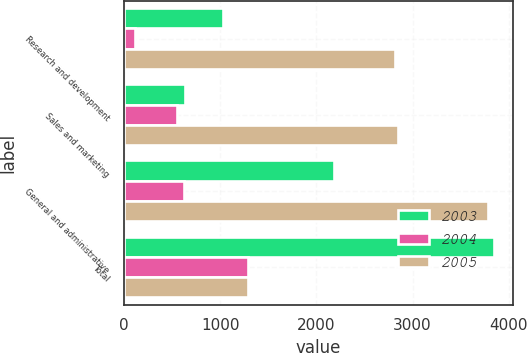<chart> <loc_0><loc_0><loc_500><loc_500><stacked_bar_chart><ecel><fcel>Research and development<fcel>Sales and marketing<fcel>General and administrative<fcel>Total<nl><fcel>2003<fcel>1034<fcel>636<fcel>2179<fcel>3849<nl><fcel>2004<fcel>118<fcel>549<fcel>621<fcel>1292<nl><fcel>2005<fcel>2819<fcel>2852<fcel>3784<fcel>1292<nl></chart> 